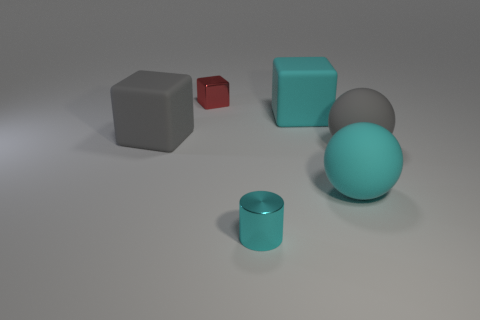How many big gray rubber things are to the right of the matte cube on the right side of the gray matte cube?
Make the answer very short. 1. How many objects are tiny things that are on the right side of the tiny cube or blocks?
Keep it short and to the point. 4. Are there any green objects that have the same shape as the small cyan object?
Ensure brevity in your answer.  No. There is a gray rubber object to the right of the metal thing that is in front of the large cyan matte block; what is its shape?
Make the answer very short. Sphere. How many cylinders are tiny green objects or gray rubber things?
Your answer should be very brief. 0. There is a large sphere that is the same color as the metallic cylinder; what is its material?
Your answer should be compact. Rubber. Is the shape of the large rubber object that is left of the small cyan metallic cylinder the same as the tiny shiny thing in front of the cyan sphere?
Give a very brief answer. No. What is the color of the large object that is both to the right of the metal block and behind the gray ball?
Offer a very short reply. Cyan. Do the metal block and the big sphere that is behind the cyan matte sphere have the same color?
Make the answer very short. No. What size is the cyan object that is both on the left side of the cyan sphere and in front of the big cyan cube?
Your response must be concise. Small. 